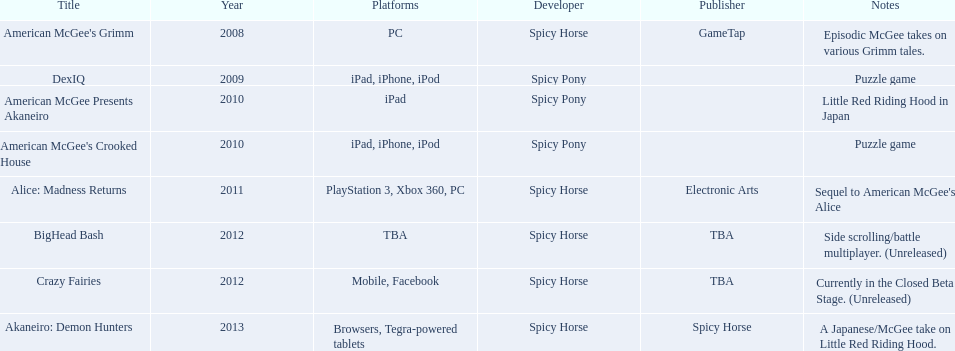What are all of the game titles? American McGee's Grimm, DexIQ, American McGee Presents Akaneiro, American McGee's Crooked House, Alice: Madness Returns, BigHead Bash, Crazy Fairies, Akaneiro: Demon Hunters. Which developer developed a game in 2011? Spicy Horse. Can you parse all the data within this table? {'header': ['Title', 'Year', 'Platforms', 'Developer', 'Publisher', 'Notes'], 'rows': [["American McGee's Grimm", '2008', 'PC', 'Spicy Horse', 'GameTap', 'Episodic McGee takes on various Grimm tales.'], ['DexIQ', '2009', 'iPad, iPhone, iPod', 'Spicy Pony', '', 'Puzzle game'], ['American McGee Presents Akaneiro', '2010', 'iPad', 'Spicy Pony', '', 'Little Red Riding Hood in Japan'], ["American McGee's Crooked House", '2010', 'iPad, iPhone, iPod', 'Spicy Pony', '', 'Puzzle game'], ['Alice: Madness Returns', '2011', 'PlayStation 3, Xbox 360, PC', 'Spicy Horse', 'Electronic Arts', "Sequel to American McGee's Alice"], ['BigHead Bash', '2012', 'TBA', 'Spicy Horse', 'TBA', 'Side scrolling/battle multiplayer. (Unreleased)'], ['Crazy Fairies', '2012', 'Mobile, Facebook', 'Spicy Horse', 'TBA', 'Currently in the Closed Beta Stage. (Unreleased)'], ['Akaneiro: Demon Hunters', '2013', 'Browsers, Tegra-powered tablets', 'Spicy Horse', 'Spicy Horse', 'A Japanese/McGee take on Little Red Riding Hood.']]} Who published this game in 2011 Electronic Arts. What was the name of this published game in 2011? Alice: Madness Returns. 